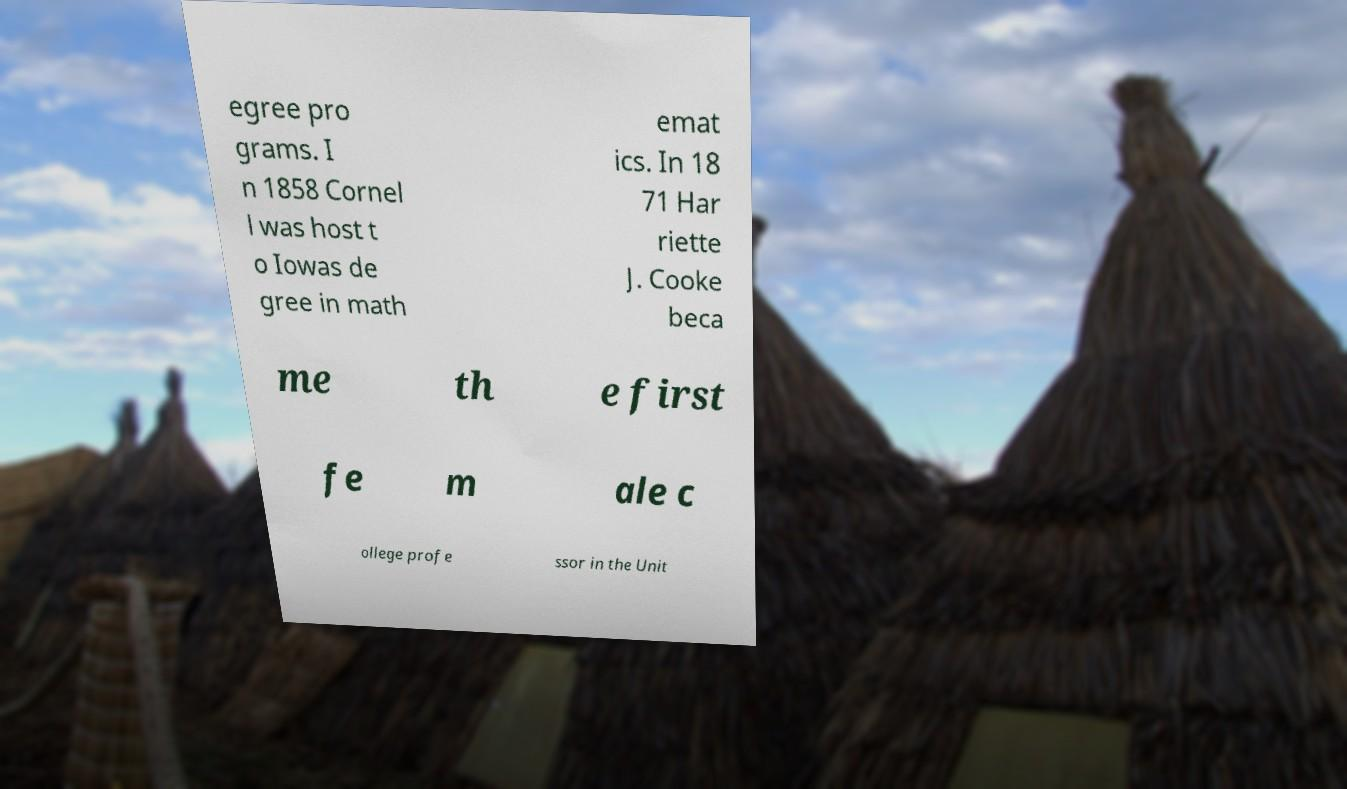I need the written content from this picture converted into text. Can you do that? egree pro grams. I n 1858 Cornel l was host t o Iowas de gree in math emat ics. In 18 71 Har riette J. Cooke beca me th e first fe m ale c ollege profe ssor in the Unit 